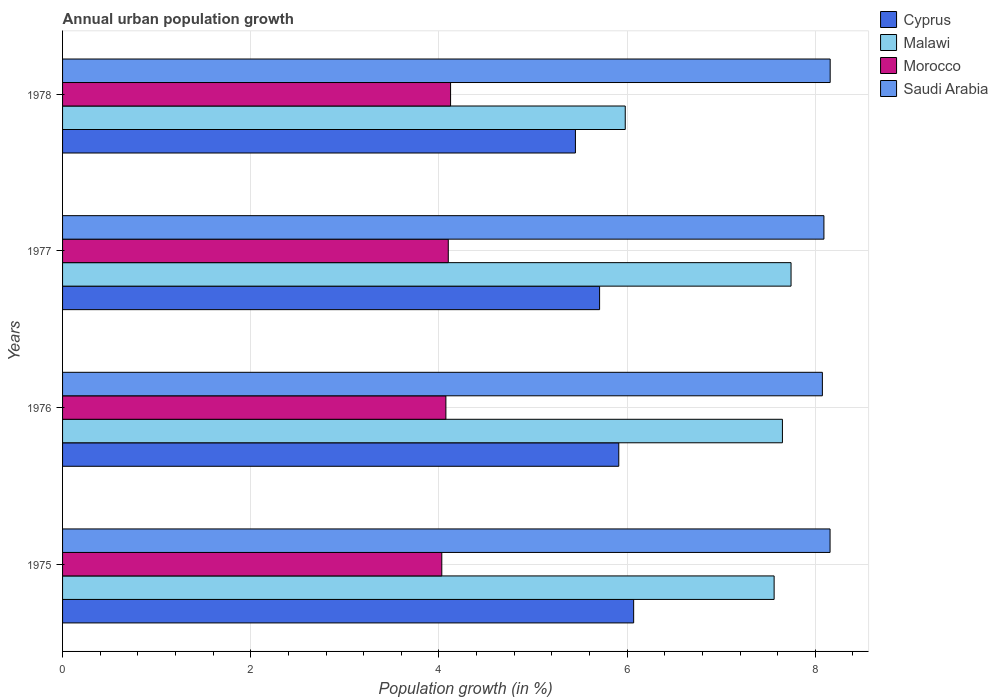How many different coloured bars are there?
Ensure brevity in your answer.  4. How many groups of bars are there?
Your answer should be very brief. 4. Are the number of bars on each tick of the Y-axis equal?
Your answer should be very brief. Yes. How many bars are there on the 4th tick from the top?
Keep it short and to the point. 4. What is the label of the 1st group of bars from the top?
Offer a very short reply. 1978. What is the percentage of urban population growth in Morocco in 1975?
Your answer should be compact. 4.03. Across all years, what is the maximum percentage of urban population growth in Morocco?
Your response must be concise. 4.12. Across all years, what is the minimum percentage of urban population growth in Malawi?
Offer a terse response. 5.98. In which year was the percentage of urban population growth in Cyprus maximum?
Keep it short and to the point. 1975. In which year was the percentage of urban population growth in Saudi Arabia minimum?
Provide a short and direct response. 1976. What is the total percentage of urban population growth in Saudi Arabia in the graph?
Provide a short and direct response. 32.48. What is the difference between the percentage of urban population growth in Saudi Arabia in 1976 and that in 1977?
Your answer should be very brief. -0.02. What is the difference between the percentage of urban population growth in Saudi Arabia in 1977 and the percentage of urban population growth in Malawi in 1976?
Offer a terse response. 0.44. What is the average percentage of urban population growth in Cyprus per year?
Give a very brief answer. 5.78. In the year 1975, what is the difference between the percentage of urban population growth in Cyprus and percentage of urban population growth in Saudi Arabia?
Offer a terse response. -2.09. What is the ratio of the percentage of urban population growth in Saudi Arabia in 1975 to that in 1977?
Offer a very short reply. 1.01. What is the difference between the highest and the second highest percentage of urban population growth in Cyprus?
Provide a succinct answer. 0.16. What is the difference between the highest and the lowest percentage of urban population growth in Cyprus?
Your answer should be very brief. 0.62. Is the sum of the percentage of urban population growth in Saudi Arabia in 1976 and 1977 greater than the maximum percentage of urban population growth in Morocco across all years?
Offer a very short reply. Yes. Is it the case that in every year, the sum of the percentage of urban population growth in Cyprus and percentage of urban population growth in Malawi is greater than the sum of percentage of urban population growth in Morocco and percentage of urban population growth in Saudi Arabia?
Give a very brief answer. No. What does the 1st bar from the top in 1976 represents?
Keep it short and to the point. Saudi Arabia. What does the 1st bar from the bottom in 1975 represents?
Your answer should be very brief. Cyprus. Are all the bars in the graph horizontal?
Keep it short and to the point. Yes. What is the title of the graph?
Make the answer very short. Annual urban population growth. What is the label or title of the X-axis?
Your answer should be compact. Population growth (in %). What is the Population growth (in %) of Cyprus in 1975?
Your answer should be compact. 6.07. What is the Population growth (in %) of Malawi in 1975?
Your answer should be very brief. 7.56. What is the Population growth (in %) of Morocco in 1975?
Provide a succinct answer. 4.03. What is the Population growth (in %) in Saudi Arabia in 1975?
Provide a succinct answer. 8.16. What is the Population growth (in %) in Cyprus in 1976?
Your answer should be very brief. 5.91. What is the Population growth (in %) of Malawi in 1976?
Give a very brief answer. 7.65. What is the Population growth (in %) of Morocco in 1976?
Your response must be concise. 4.07. What is the Population growth (in %) in Saudi Arabia in 1976?
Make the answer very short. 8.07. What is the Population growth (in %) in Cyprus in 1977?
Keep it short and to the point. 5.71. What is the Population growth (in %) of Malawi in 1977?
Keep it short and to the point. 7.74. What is the Population growth (in %) in Morocco in 1977?
Provide a short and direct response. 4.1. What is the Population growth (in %) in Saudi Arabia in 1977?
Your response must be concise. 8.09. What is the Population growth (in %) in Cyprus in 1978?
Your answer should be very brief. 5.45. What is the Population growth (in %) of Malawi in 1978?
Make the answer very short. 5.98. What is the Population growth (in %) in Morocco in 1978?
Your answer should be very brief. 4.12. What is the Population growth (in %) of Saudi Arabia in 1978?
Keep it short and to the point. 8.16. Across all years, what is the maximum Population growth (in %) in Cyprus?
Offer a terse response. 6.07. Across all years, what is the maximum Population growth (in %) of Malawi?
Your answer should be very brief. 7.74. Across all years, what is the maximum Population growth (in %) of Morocco?
Give a very brief answer. 4.12. Across all years, what is the maximum Population growth (in %) of Saudi Arabia?
Give a very brief answer. 8.16. Across all years, what is the minimum Population growth (in %) in Cyprus?
Keep it short and to the point. 5.45. Across all years, what is the minimum Population growth (in %) in Malawi?
Your answer should be very brief. 5.98. Across all years, what is the minimum Population growth (in %) of Morocco?
Give a very brief answer. 4.03. Across all years, what is the minimum Population growth (in %) of Saudi Arabia?
Offer a very short reply. 8.07. What is the total Population growth (in %) in Cyprus in the graph?
Offer a very short reply. 23.14. What is the total Population growth (in %) of Malawi in the graph?
Offer a very short reply. 28.93. What is the total Population growth (in %) of Morocco in the graph?
Ensure brevity in your answer.  16.33. What is the total Population growth (in %) of Saudi Arabia in the graph?
Offer a terse response. 32.48. What is the difference between the Population growth (in %) in Cyprus in 1975 and that in 1976?
Keep it short and to the point. 0.16. What is the difference between the Population growth (in %) of Malawi in 1975 and that in 1976?
Your answer should be very brief. -0.09. What is the difference between the Population growth (in %) in Morocco in 1975 and that in 1976?
Keep it short and to the point. -0.04. What is the difference between the Population growth (in %) in Saudi Arabia in 1975 and that in 1976?
Give a very brief answer. 0.08. What is the difference between the Population growth (in %) of Cyprus in 1975 and that in 1977?
Offer a terse response. 0.36. What is the difference between the Population growth (in %) of Malawi in 1975 and that in 1977?
Offer a very short reply. -0.18. What is the difference between the Population growth (in %) of Morocco in 1975 and that in 1977?
Provide a succinct answer. -0.07. What is the difference between the Population growth (in %) of Saudi Arabia in 1975 and that in 1977?
Your response must be concise. 0.07. What is the difference between the Population growth (in %) in Cyprus in 1975 and that in 1978?
Make the answer very short. 0.62. What is the difference between the Population growth (in %) in Malawi in 1975 and that in 1978?
Provide a short and direct response. 1.58. What is the difference between the Population growth (in %) in Morocco in 1975 and that in 1978?
Make the answer very short. -0.09. What is the difference between the Population growth (in %) in Saudi Arabia in 1975 and that in 1978?
Provide a short and direct response. -0. What is the difference between the Population growth (in %) of Cyprus in 1976 and that in 1977?
Offer a terse response. 0.2. What is the difference between the Population growth (in %) of Malawi in 1976 and that in 1977?
Your response must be concise. -0.09. What is the difference between the Population growth (in %) in Morocco in 1976 and that in 1977?
Provide a succinct answer. -0.03. What is the difference between the Population growth (in %) of Saudi Arabia in 1976 and that in 1977?
Your answer should be very brief. -0.02. What is the difference between the Population growth (in %) in Cyprus in 1976 and that in 1978?
Your answer should be very brief. 0.46. What is the difference between the Population growth (in %) in Malawi in 1976 and that in 1978?
Your answer should be compact. 1.67. What is the difference between the Population growth (in %) in Morocco in 1976 and that in 1978?
Ensure brevity in your answer.  -0.05. What is the difference between the Population growth (in %) in Saudi Arabia in 1976 and that in 1978?
Offer a very short reply. -0.08. What is the difference between the Population growth (in %) of Cyprus in 1977 and that in 1978?
Keep it short and to the point. 0.26. What is the difference between the Population growth (in %) in Malawi in 1977 and that in 1978?
Give a very brief answer. 1.76. What is the difference between the Population growth (in %) of Morocco in 1977 and that in 1978?
Your response must be concise. -0.02. What is the difference between the Population growth (in %) of Saudi Arabia in 1977 and that in 1978?
Keep it short and to the point. -0.07. What is the difference between the Population growth (in %) of Cyprus in 1975 and the Population growth (in %) of Malawi in 1976?
Your answer should be very brief. -1.58. What is the difference between the Population growth (in %) of Cyprus in 1975 and the Population growth (in %) of Morocco in 1976?
Ensure brevity in your answer.  2. What is the difference between the Population growth (in %) in Cyprus in 1975 and the Population growth (in %) in Saudi Arabia in 1976?
Your response must be concise. -2.01. What is the difference between the Population growth (in %) in Malawi in 1975 and the Population growth (in %) in Morocco in 1976?
Offer a terse response. 3.49. What is the difference between the Population growth (in %) in Malawi in 1975 and the Population growth (in %) in Saudi Arabia in 1976?
Give a very brief answer. -0.51. What is the difference between the Population growth (in %) of Morocco in 1975 and the Population growth (in %) of Saudi Arabia in 1976?
Ensure brevity in your answer.  -4.04. What is the difference between the Population growth (in %) in Cyprus in 1975 and the Population growth (in %) in Malawi in 1977?
Offer a terse response. -1.67. What is the difference between the Population growth (in %) of Cyprus in 1975 and the Population growth (in %) of Morocco in 1977?
Provide a short and direct response. 1.97. What is the difference between the Population growth (in %) of Cyprus in 1975 and the Population growth (in %) of Saudi Arabia in 1977?
Make the answer very short. -2.02. What is the difference between the Population growth (in %) in Malawi in 1975 and the Population growth (in %) in Morocco in 1977?
Provide a short and direct response. 3.46. What is the difference between the Population growth (in %) of Malawi in 1975 and the Population growth (in %) of Saudi Arabia in 1977?
Give a very brief answer. -0.53. What is the difference between the Population growth (in %) of Morocco in 1975 and the Population growth (in %) of Saudi Arabia in 1977?
Provide a succinct answer. -4.06. What is the difference between the Population growth (in %) of Cyprus in 1975 and the Population growth (in %) of Malawi in 1978?
Give a very brief answer. 0.09. What is the difference between the Population growth (in %) of Cyprus in 1975 and the Population growth (in %) of Morocco in 1978?
Ensure brevity in your answer.  1.95. What is the difference between the Population growth (in %) of Cyprus in 1975 and the Population growth (in %) of Saudi Arabia in 1978?
Keep it short and to the point. -2.09. What is the difference between the Population growth (in %) of Malawi in 1975 and the Population growth (in %) of Morocco in 1978?
Make the answer very short. 3.44. What is the difference between the Population growth (in %) in Malawi in 1975 and the Population growth (in %) in Saudi Arabia in 1978?
Give a very brief answer. -0.6. What is the difference between the Population growth (in %) of Morocco in 1975 and the Population growth (in %) of Saudi Arabia in 1978?
Your answer should be very brief. -4.13. What is the difference between the Population growth (in %) in Cyprus in 1976 and the Population growth (in %) in Malawi in 1977?
Your answer should be very brief. -1.83. What is the difference between the Population growth (in %) in Cyprus in 1976 and the Population growth (in %) in Morocco in 1977?
Keep it short and to the point. 1.81. What is the difference between the Population growth (in %) in Cyprus in 1976 and the Population growth (in %) in Saudi Arabia in 1977?
Keep it short and to the point. -2.18. What is the difference between the Population growth (in %) in Malawi in 1976 and the Population growth (in %) in Morocco in 1977?
Offer a terse response. 3.55. What is the difference between the Population growth (in %) in Malawi in 1976 and the Population growth (in %) in Saudi Arabia in 1977?
Your response must be concise. -0.44. What is the difference between the Population growth (in %) in Morocco in 1976 and the Population growth (in %) in Saudi Arabia in 1977?
Your answer should be compact. -4.02. What is the difference between the Population growth (in %) of Cyprus in 1976 and the Population growth (in %) of Malawi in 1978?
Provide a succinct answer. -0.07. What is the difference between the Population growth (in %) in Cyprus in 1976 and the Population growth (in %) in Morocco in 1978?
Your answer should be compact. 1.79. What is the difference between the Population growth (in %) of Cyprus in 1976 and the Population growth (in %) of Saudi Arabia in 1978?
Offer a very short reply. -2.25. What is the difference between the Population growth (in %) of Malawi in 1976 and the Population growth (in %) of Morocco in 1978?
Provide a short and direct response. 3.53. What is the difference between the Population growth (in %) in Malawi in 1976 and the Population growth (in %) in Saudi Arabia in 1978?
Your answer should be very brief. -0.51. What is the difference between the Population growth (in %) in Morocco in 1976 and the Population growth (in %) in Saudi Arabia in 1978?
Provide a short and direct response. -4.08. What is the difference between the Population growth (in %) of Cyprus in 1977 and the Population growth (in %) of Malawi in 1978?
Offer a terse response. -0.27. What is the difference between the Population growth (in %) in Cyprus in 1977 and the Population growth (in %) in Morocco in 1978?
Your answer should be very brief. 1.58. What is the difference between the Population growth (in %) in Cyprus in 1977 and the Population growth (in %) in Saudi Arabia in 1978?
Ensure brevity in your answer.  -2.45. What is the difference between the Population growth (in %) in Malawi in 1977 and the Population growth (in %) in Morocco in 1978?
Make the answer very short. 3.62. What is the difference between the Population growth (in %) in Malawi in 1977 and the Population growth (in %) in Saudi Arabia in 1978?
Give a very brief answer. -0.42. What is the difference between the Population growth (in %) of Morocco in 1977 and the Population growth (in %) of Saudi Arabia in 1978?
Your response must be concise. -4.06. What is the average Population growth (in %) in Cyprus per year?
Provide a succinct answer. 5.78. What is the average Population growth (in %) in Malawi per year?
Keep it short and to the point. 7.23. What is the average Population growth (in %) of Morocco per year?
Offer a terse response. 4.08. What is the average Population growth (in %) in Saudi Arabia per year?
Keep it short and to the point. 8.12. In the year 1975, what is the difference between the Population growth (in %) in Cyprus and Population growth (in %) in Malawi?
Make the answer very short. -1.49. In the year 1975, what is the difference between the Population growth (in %) of Cyprus and Population growth (in %) of Morocco?
Provide a succinct answer. 2.04. In the year 1975, what is the difference between the Population growth (in %) in Cyprus and Population growth (in %) in Saudi Arabia?
Provide a short and direct response. -2.09. In the year 1975, what is the difference between the Population growth (in %) of Malawi and Population growth (in %) of Morocco?
Provide a succinct answer. 3.53. In the year 1975, what is the difference between the Population growth (in %) in Malawi and Population growth (in %) in Saudi Arabia?
Provide a short and direct response. -0.59. In the year 1975, what is the difference between the Population growth (in %) of Morocco and Population growth (in %) of Saudi Arabia?
Keep it short and to the point. -4.13. In the year 1976, what is the difference between the Population growth (in %) of Cyprus and Population growth (in %) of Malawi?
Make the answer very short. -1.74. In the year 1976, what is the difference between the Population growth (in %) in Cyprus and Population growth (in %) in Morocco?
Your response must be concise. 1.84. In the year 1976, what is the difference between the Population growth (in %) of Cyprus and Population growth (in %) of Saudi Arabia?
Give a very brief answer. -2.16. In the year 1976, what is the difference between the Population growth (in %) in Malawi and Population growth (in %) in Morocco?
Your response must be concise. 3.58. In the year 1976, what is the difference between the Population growth (in %) in Malawi and Population growth (in %) in Saudi Arabia?
Your answer should be compact. -0.42. In the year 1976, what is the difference between the Population growth (in %) in Morocco and Population growth (in %) in Saudi Arabia?
Your answer should be very brief. -4. In the year 1977, what is the difference between the Population growth (in %) of Cyprus and Population growth (in %) of Malawi?
Provide a short and direct response. -2.03. In the year 1977, what is the difference between the Population growth (in %) of Cyprus and Population growth (in %) of Morocco?
Make the answer very short. 1.61. In the year 1977, what is the difference between the Population growth (in %) in Cyprus and Population growth (in %) in Saudi Arabia?
Give a very brief answer. -2.38. In the year 1977, what is the difference between the Population growth (in %) in Malawi and Population growth (in %) in Morocco?
Ensure brevity in your answer.  3.64. In the year 1977, what is the difference between the Population growth (in %) in Malawi and Population growth (in %) in Saudi Arabia?
Offer a terse response. -0.35. In the year 1977, what is the difference between the Population growth (in %) of Morocco and Population growth (in %) of Saudi Arabia?
Your answer should be compact. -3.99. In the year 1978, what is the difference between the Population growth (in %) in Cyprus and Population growth (in %) in Malawi?
Provide a succinct answer. -0.53. In the year 1978, what is the difference between the Population growth (in %) in Cyprus and Population growth (in %) in Morocco?
Give a very brief answer. 1.33. In the year 1978, what is the difference between the Population growth (in %) of Cyprus and Population growth (in %) of Saudi Arabia?
Your answer should be compact. -2.71. In the year 1978, what is the difference between the Population growth (in %) in Malawi and Population growth (in %) in Morocco?
Provide a succinct answer. 1.86. In the year 1978, what is the difference between the Population growth (in %) in Malawi and Population growth (in %) in Saudi Arabia?
Make the answer very short. -2.18. In the year 1978, what is the difference between the Population growth (in %) in Morocco and Population growth (in %) in Saudi Arabia?
Your answer should be compact. -4.03. What is the ratio of the Population growth (in %) in Cyprus in 1975 to that in 1976?
Your response must be concise. 1.03. What is the ratio of the Population growth (in %) in Malawi in 1975 to that in 1976?
Provide a short and direct response. 0.99. What is the ratio of the Population growth (in %) in Morocco in 1975 to that in 1976?
Offer a terse response. 0.99. What is the ratio of the Population growth (in %) of Cyprus in 1975 to that in 1977?
Offer a terse response. 1.06. What is the ratio of the Population growth (in %) in Malawi in 1975 to that in 1977?
Ensure brevity in your answer.  0.98. What is the ratio of the Population growth (in %) of Morocco in 1975 to that in 1977?
Offer a very short reply. 0.98. What is the ratio of the Population growth (in %) in Saudi Arabia in 1975 to that in 1977?
Offer a terse response. 1.01. What is the ratio of the Population growth (in %) in Cyprus in 1975 to that in 1978?
Ensure brevity in your answer.  1.11. What is the ratio of the Population growth (in %) of Malawi in 1975 to that in 1978?
Make the answer very short. 1.26. What is the ratio of the Population growth (in %) of Morocco in 1975 to that in 1978?
Offer a terse response. 0.98. What is the ratio of the Population growth (in %) in Cyprus in 1976 to that in 1977?
Give a very brief answer. 1.04. What is the ratio of the Population growth (in %) in Cyprus in 1976 to that in 1978?
Offer a very short reply. 1.08. What is the ratio of the Population growth (in %) of Malawi in 1976 to that in 1978?
Ensure brevity in your answer.  1.28. What is the ratio of the Population growth (in %) of Morocco in 1976 to that in 1978?
Give a very brief answer. 0.99. What is the ratio of the Population growth (in %) in Saudi Arabia in 1976 to that in 1978?
Provide a succinct answer. 0.99. What is the ratio of the Population growth (in %) in Cyprus in 1977 to that in 1978?
Offer a terse response. 1.05. What is the ratio of the Population growth (in %) of Malawi in 1977 to that in 1978?
Provide a succinct answer. 1.29. What is the ratio of the Population growth (in %) in Saudi Arabia in 1977 to that in 1978?
Provide a short and direct response. 0.99. What is the difference between the highest and the second highest Population growth (in %) in Cyprus?
Ensure brevity in your answer.  0.16. What is the difference between the highest and the second highest Population growth (in %) in Malawi?
Your answer should be very brief. 0.09. What is the difference between the highest and the second highest Population growth (in %) in Morocco?
Provide a short and direct response. 0.02. What is the difference between the highest and the second highest Population growth (in %) of Saudi Arabia?
Provide a short and direct response. 0. What is the difference between the highest and the lowest Population growth (in %) in Cyprus?
Your answer should be very brief. 0.62. What is the difference between the highest and the lowest Population growth (in %) in Malawi?
Provide a succinct answer. 1.76. What is the difference between the highest and the lowest Population growth (in %) of Morocco?
Your answer should be compact. 0.09. What is the difference between the highest and the lowest Population growth (in %) in Saudi Arabia?
Keep it short and to the point. 0.08. 